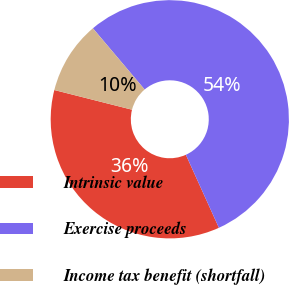Convert chart to OTSL. <chart><loc_0><loc_0><loc_500><loc_500><pie_chart><fcel>Intrinsic value<fcel>Exercise proceeds<fcel>Income tax benefit (shortfall)<nl><fcel>35.71%<fcel>54.4%<fcel>9.88%<nl></chart> 